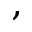<formula> <loc_0><loc_0><loc_500><loc_500>,</formula> 